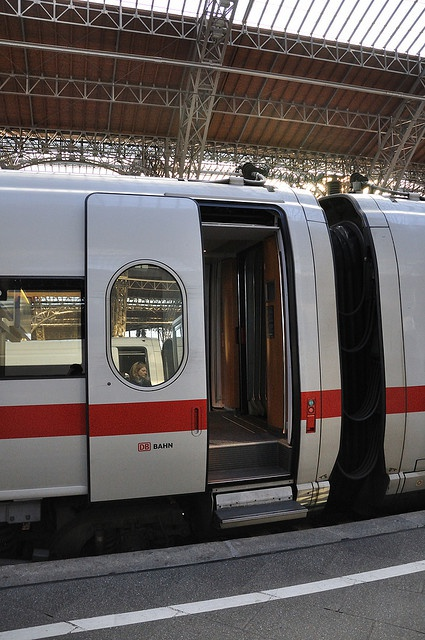Describe the objects in this image and their specific colors. I can see train in black, darkgray, gray, and maroon tones and people in black and gray tones in this image. 